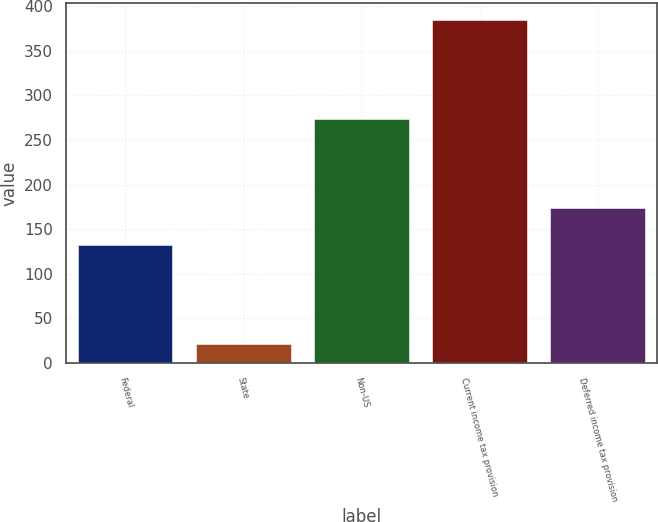<chart> <loc_0><loc_0><loc_500><loc_500><bar_chart><fcel>Federal<fcel>State<fcel>Non-US<fcel>Current income tax provision<fcel>Deferred income tax provision<nl><fcel>132<fcel>21<fcel>273<fcel>384<fcel>174<nl></chart> 